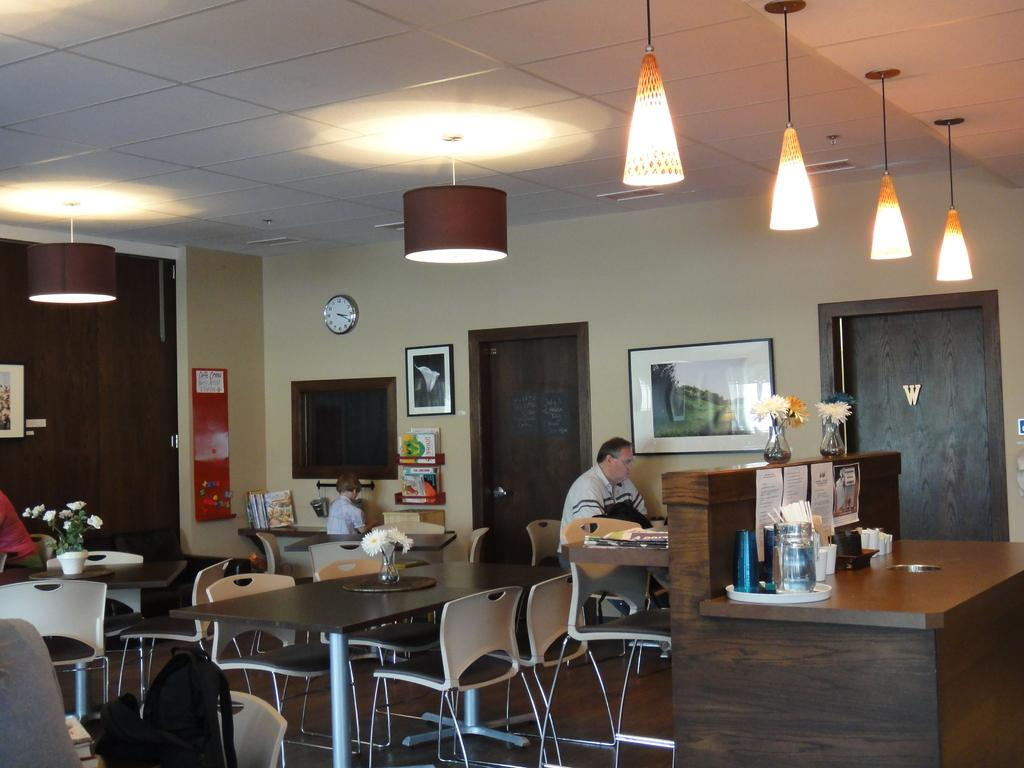What is the man in the image doing? The man is sitting on a chair in the image. What is located near the man? There is a table in the image. What is on the table? There is a flower vase on the table. Who else is present in the image? There is a boy in the image. What can be seen in the background of the image? There is a wall, frames, lights, doors, and papers in the background of the image. What type of collar is the man wearing in the image? There is no collar visible in the image, as the man is not wearing any clothing that would have a collar. What type of dress is the boy wearing in the image? There is no dress visible in the image, as the boy is not wearing any clothing that would be considered a dress. 